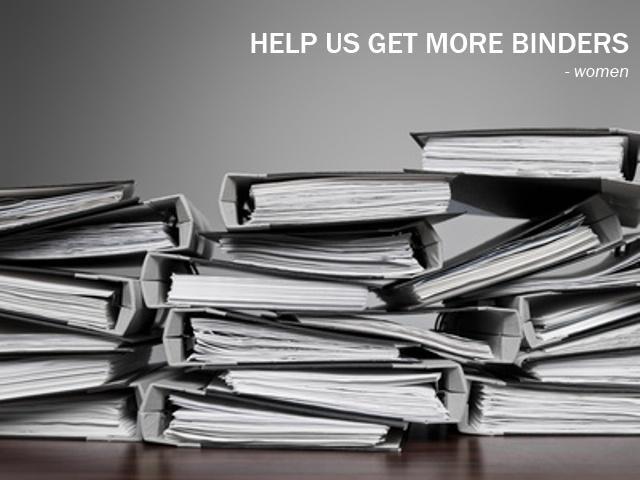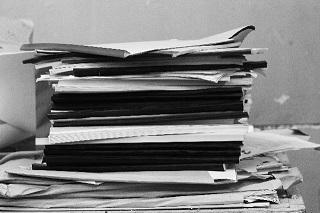The first image is the image on the left, the second image is the image on the right. Evaluate the accuracy of this statement regarding the images: "An image shows the labeled ends of three stacked binders of different colors.". Is it true? Answer yes or no. No. The first image is the image on the left, the second image is the image on the right. Considering the images on both sides, is "The left image has binders with visible labels." valid? Answer yes or no. No. 